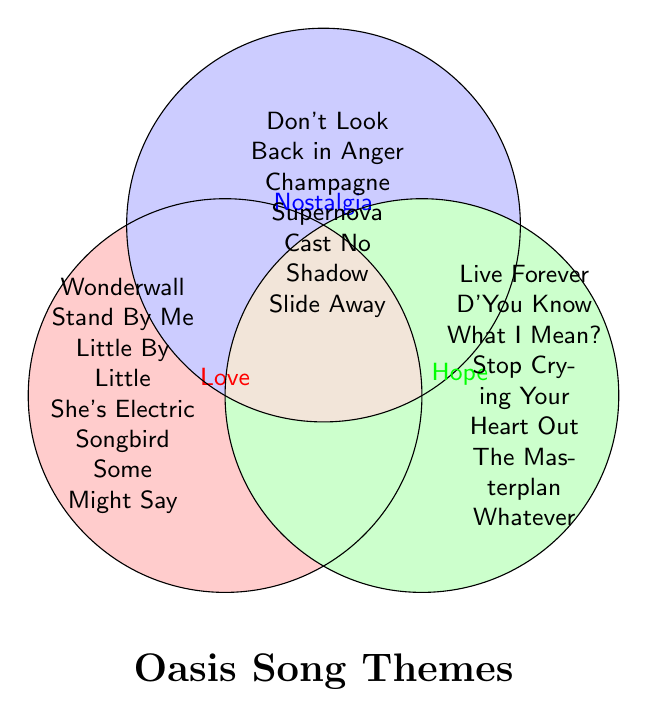What's the title of the figure? The title is displayed prominently below the main Venn Diagram image.
Answer: Oasis Song Themes Which songs are in the 'Love' theme? Look at the section labeled "Love" and note the songs listed within its area.
Answer: Wonderwall, Stand By Me, Little By Little, She's Electric, Songbird, Some Might Say Are there any songs that are exclusively in the 'Hope' theme? Check the area labeled "Hope" and ensure it doesn't overlap with 'Love' or 'Nostalgia' sections.
Answer: Live Forever, D'You Know What I Mean?, Stop Crying Your Heart Out, The Masterplan, Whatever Which theme contains "Slide Away"? Find "Slide Away" in one of the theme areas to determine which theme it belongs to.
Answer: Nostalgia Name a song that combines 'Love' and 'Nostalgia' themes. Look for songs listed in the overlapping area between 'Love' and 'Nostalgia' sections.
Answer: None How many songs are exclusively under the 'Love' theme but not in 'Hope' or 'Nostalgia'? Identify the songs in the 'Love' section that don't overlap with other sections.
Answer: 6 songs: Wonderwall, Stand By Me, Little By Little, She's Electric, Songbird, Some Might Say Which themes encompass the song "Don't Look Back in Anger"? Check where "Don't Look Back in Anger" is located to see which themes overlap that section.
Answer: Nostalgia How many songs are classified under both 'Nostalgia' and 'Hope'? Identify the songs listed in the overlapping area between 'Nostalgia' and 'Hope'.
Answer: 0 songs Which song titles appear multiple times across different themes? Scan for repetitions of song titles across the distinct or overlapping theme areas.
Answer: None 